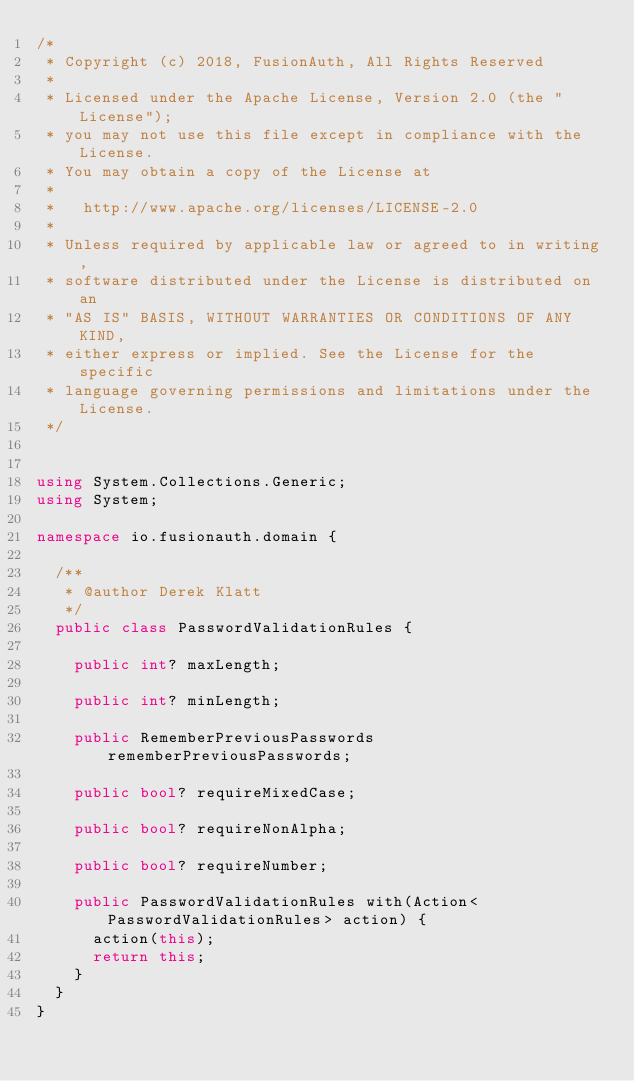<code> <loc_0><loc_0><loc_500><loc_500><_C#_>/*
 * Copyright (c) 2018, FusionAuth, All Rights Reserved
 *
 * Licensed under the Apache License, Version 2.0 (the "License");
 * you may not use this file except in compliance with the License.
 * You may obtain a copy of the License at
 *
 *   http://www.apache.org/licenses/LICENSE-2.0
 *
 * Unless required by applicable law or agreed to in writing,
 * software distributed under the License is distributed on an
 * "AS IS" BASIS, WITHOUT WARRANTIES OR CONDITIONS OF ANY KIND,
 * either express or implied. See the License for the specific
 * language governing permissions and limitations under the License.
 */


using System.Collections.Generic;
using System;

namespace io.fusionauth.domain {

  /**
   * @author Derek Klatt
   */
  public class PasswordValidationRules {

    public int? maxLength;

    public int? minLength;

    public RememberPreviousPasswords rememberPreviousPasswords;

    public bool? requireMixedCase;

    public bool? requireNonAlpha;

    public bool? requireNumber;

    public PasswordValidationRules with(Action<PasswordValidationRules> action) {
      action(this);
      return this;
    }
  }
}
</code> 